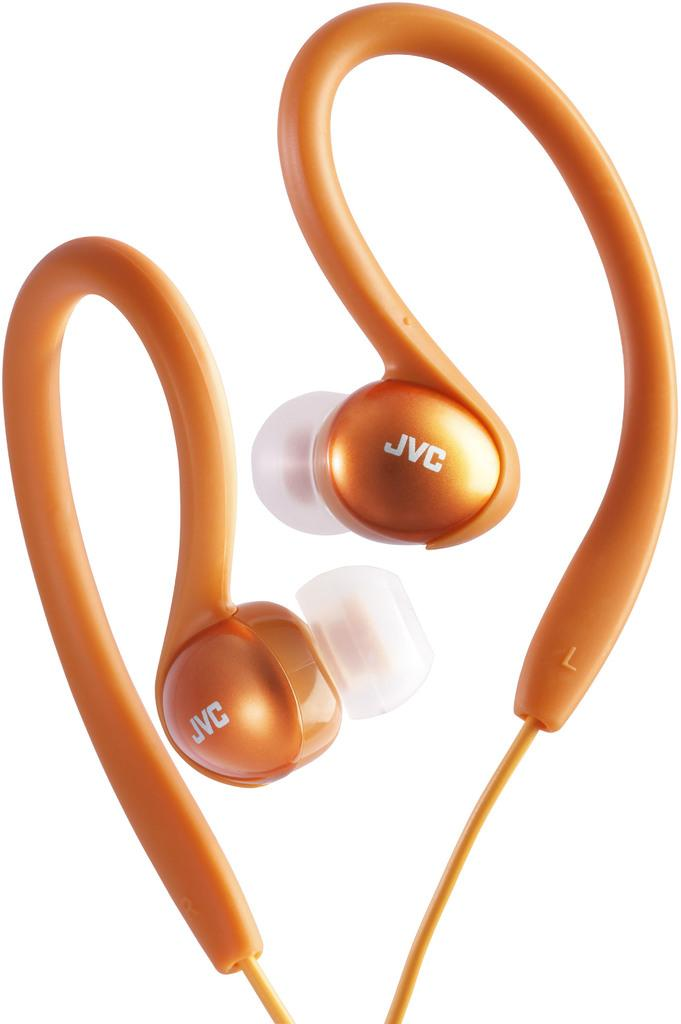Provide a one-sentence caption for the provided image. A pair of orange colored JVC earphones that curve over the top of ears. 